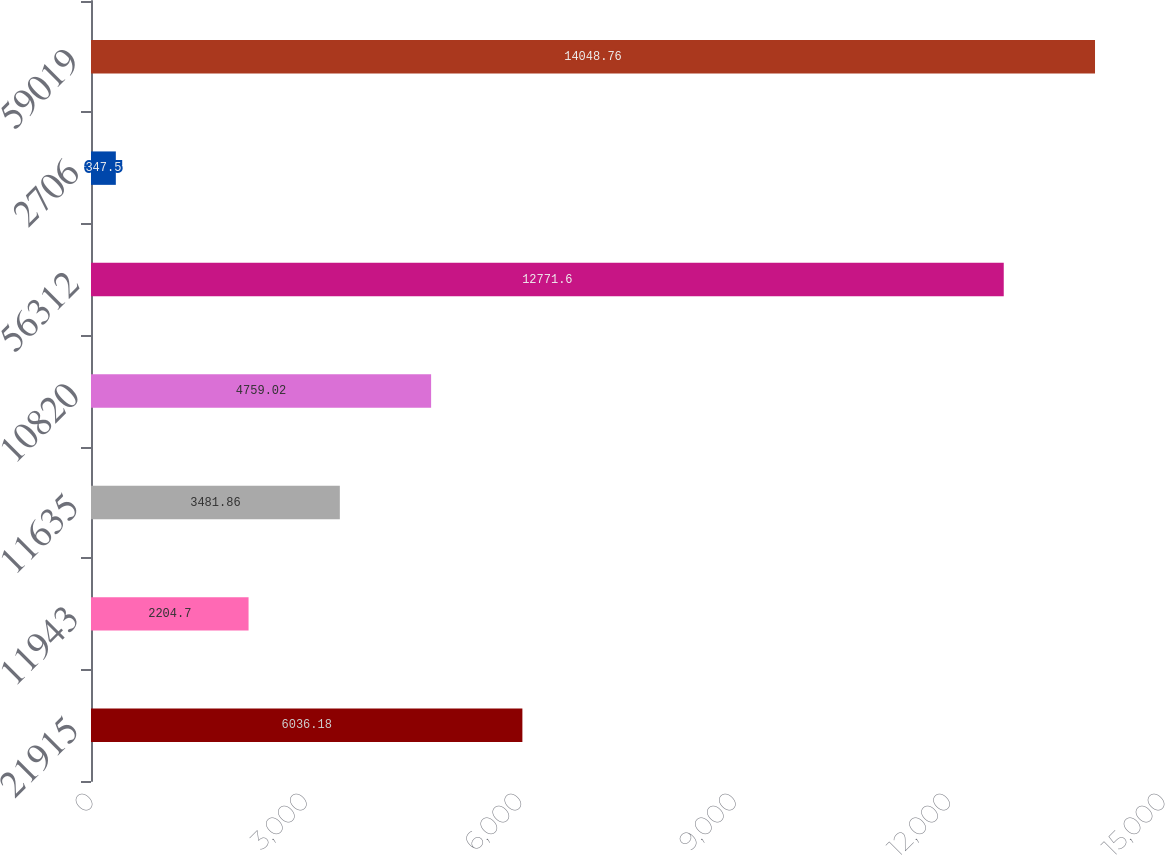Convert chart. <chart><loc_0><loc_0><loc_500><loc_500><bar_chart><fcel>21915<fcel>11943<fcel>11635<fcel>10820<fcel>56312<fcel>2706<fcel>59019<nl><fcel>6036.18<fcel>2204.7<fcel>3481.86<fcel>4759.02<fcel>12771.6<fcel>347.5<fcel>14048.8<nl></chart> 